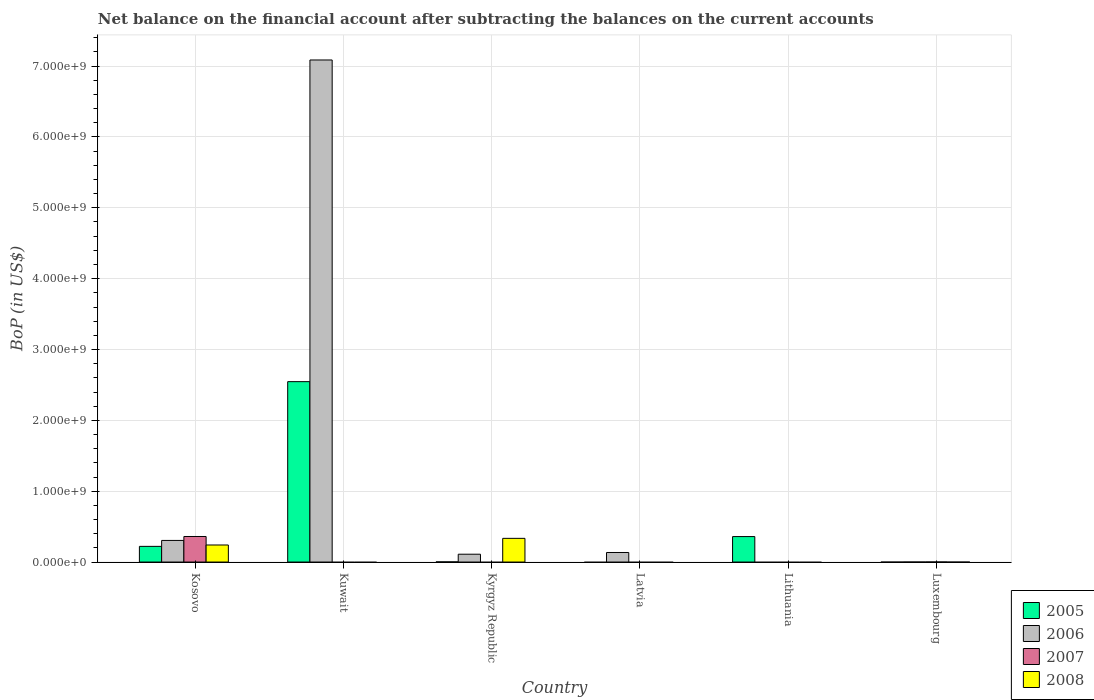What is the label of the 5th group of bars from the left?
Provide a short and direct response. Lithuania. In how many cases, is the number of bars for a given country not equal to the number of legend labels?
Make the answer very short. 5. What is the Balance of Payments in 2006 in Kuwait?
Offer a terse response. 7.09e+09. Across all countries, what is the maximum Balance of Payments in 2006?
Give a very brief answer. 7.09e+09. In which country was the Balance of Payments in 2008 maximum?
Ensure brevity in your answer.  Kyrgyz Republic. What is the total Balance of Payments in 2008 in the graph?
Your answer should be very brief. 5.75e+08. What is the difference between the Balance of Payments in 2005 in Kuwait and that in Lithuania?
Your response must be concise. 2.19e+09. What is the difference between the Balance of Payments in 2007 in Kyrgyz Republic and the Balance of Payments in 2006 in Lithuania?
Provide a succinct answer. 0. What is the average Balance of Payments in 2008 per country?
Your answer should be very brief. 9.58e+07. What is the difference between the Balance of Payments of/in 2008 and Balance of Payments of/in 2006 in Kyrgyz Republic?
Your answer should be very brief. 2.24e+08. In how many countries, is the Balance of Payments in 2005 greater than 3600000000 US$?
Make the answer very short. 0. What is the ratio of the Balance of Payments in 2005 in Kosovo to that in Kuwait?
Provide a succinct answer. 0.09. Is the Balance of Payments in 2005 in Kosovo less than that in Lithuania?
Ensure brevity in your answer.  Yes. What is the difference between the highest and the second highest Balance of Payments in 2006?
Make the answer very short. -6.78e+09. What is the difference between the highest and the lowest Balance of Payments in 2007?
Ensure brevity in your answer.  3.60e+08. In how many countries, is the Balance of Payments in 2006 greater than the average Balance of Payments in 2006 taken over all countries?
Your answer should be very brief. 1. Is it the case that in every country, the sum of the Balance of Payments in 2007 and Balance of Payments in 2008 is greater than the Balance of Payments in 2005?
Your answer should be very brief. No. Are all the bars in the graph horizontal?
Give a very brief answer. No. Are the values on the major ticks of Y-axis written in scientific E-notation?
Provide a succinct answer. Yes. Does the graph contain any zero values?
Keep it short and to the point. Yes. Where does the legend appear in the graph?
Ensure brevity in your answer.  Bottom right. How many legend labels are there?
Offer a very short reply. 4. What is the title of the graph?
Your response must be concise. Net balance on the financial account after subtracting the balances on the current accounts. What is the label or title of the Y-axis?
Ensure brevity in your answer.  BoP (in US$). What is the BoP (in US$) of 2005 in Kosovo?
Keep it short and to the point. 2.21e+08. What is the BoP (in US$) of 2006 in Kosovo?
Offer a terse response. 3.05e+08. What is the BoP (in US$) in 2007 in Kosovo?
Offer a very short reply. 3.60e+08. What is the BoP (in US$) of 2008 in Kosovo?
Offer a very short reply. 2.41e+08. What is the BoP (in US$) of 2005 in Kuwait?
Offer a terse response. 2.55e+09. What is the BoP (in US$) of 2006 in Kuwait?
Make the answer very short. 7.09e+09. What is the BoP (in US$) in 2007 in Kuwait?
Make the answer very short. 0. What is the BoP (in US$) in 2008 in Kuwait?
Make the answer very short. 0. What is the BoP (in US$) in 2005 in Kyrgyz Republic?
Offer a very short reply. 2.12e+06. What is the BoP (in US$) in 2006 in Kyrgyz Republic?
Give a very brief answer. 1.10e+08. What is the BoP (in US$) of 2007 in Kyrgyz Republic?
Give a very brief answer. 0. What is the BoP (in US$) of 2008 in Kyrgyz Republic?
Offer a terse response. 3.34e+08. What is the BoP (in US$) of 2005 in Latvia?
Your response must be concise. 0. What is the BoP (in US$) in 2006 in Latvia?
Your answer should be compact. 1.35e+08. What is the BoP (in US$) of 2008 in Latvia?
Your answer should be very brief. 0. What is the BoP (in US$) in 2005 in Lithuania?
Your response must be concise. 3.60e+08. What is the BoP (in US$) in 2006 in Luxembourg?
Ensure brevity in your answer.  0. What is the BoP (in US$) of 2007 in Luxembourg?
Your answer should be compact. 4.90e+05. What is the BoP (in US$) in 2008 in Luxembourg?
Offer a very short reply. 0. Across all countries, what is the maximum BoP (in US$) of 2005?
Give a very brief answer. 2.55e+09. Across all countries, what is the maximum BoP (in US$) of 2006?
Provide a succinct answer. 7.09e+09. Across all countries, what is the maximum BoP (in US$) in 2007?
Your answer should be very brief. 3.60e+08. Across all countries, what is the maximum BoP (in US$) in 2008?
Your answer should be compact. 3.34e+08. Across all countries, what is the minimum BoP (in US$) in 2005?
Give a very brief answer. 0. Across all countries, what is the minimum BoP (in US$) of 2007?
Your answer should be very brief. 0. What is the total BoP (in US$) in 2005 in the graph?
Offer a terse response. 3.13e+09. What is the total BoP (in US$) of 2006 in the graph?
Provide a short and direct response. 7.64e+09. What is the total BoP (in US$) of 2007 in the graph?
Your answer should be very brief. 3.61e+08. What is the total BoP (in US$) in 2008 in the graph?
Ensure brevity in your answer.  5.75e+08. What is the difference between the BoP (in US$) in 2005 in Kosovo and that in Kuwait?
Your response must be concise. -2.33e+09. What is the difference between the BoP (in US$) of 2006 in Kosovo and that in Kuwait?
Offer a very short reply. -6.78e+09. What is the difference between the BoP (in US$) of 2005 in Kosovo and that in Kyrgyz Republic?
Provide a succinct answer. 2.19e+08. What is the difference between the BoP (in US$) of 2006 in Kosovo and that in Kyrgyz Republic?
Your response must be concise. 1.95e+08. What is the difference between the BoP (in US$) of 2008 in Kosovo and that in Kyrgyz Republic?
Provide a succinct answer. -9.37e+07. What is the difference between the BoP (in US$) of 2006 in Kosovo and that in Latvia?
Keep it short and to the point. 1.70e+08. What is the difference between the BoP (in US$) in 2005 in Kosovo and that in Lithuania?
Offer a terse response. -1.38e+08. What is the difference between the BoP (in US$) in 2007 in Kosovo and that in Luxembourg?
Give a very brief answer. 3.60e+08. What is the difference between the BoP (in US$) of 2005 in Kuwait and that in Kyrgyz Republic?
Your response must be concise. 2.54e+09. What is the difference between the BoP (in US$) of 2006 in Kuwait and that in Kyrgyz Republic?
Provide a short and direct response. 6.98e+09. What is the difference between the BoP (in US$) in 2006 in Kuwait and that in Latvia?
Give a very brief answer. 6.95e+09. What is the difference between the BoP (in US$) of 2005 in Kuwait and that in Lithuania?
Make the answer very short. 2.19e+09. What is the difference between the BoP (in US$) of 2006 in Kyrgyz Republic and that in Latvia?
Give a very brief answer. -2.42e+07. What is the difference between the BoP (in US$) of 2005 in Kyrgyz Republic and that in Lithuania?
Your response must be concise. -3.57e+08. What is the difference between the BoP (in US$) in 2005 in Kosovo and the BoP (in US$) in 2006 in Kuwait?
Your response must be concise. -6.87e+09. What is the difference between the BoP (in US$) of 2005 in Kosovo and the BoP (in US$) of 2006 in Kyrgyz Republic?
Your answer should be very brief. 1.11e+08. What is the difference between the BoP (in US$) in 2005 in Kosovo and the BoP (in US$) in 2008 in Kyrgyz Republic?
Your answer should be compact. -1.13e+08. What is the difference between the BoP (in US$) in 2006 in Kosovo and the BoP (in US$) in 2008 in Kyrgyz Republic?
Ensure brevity in your answer.  -2.94e+07. What is the difference between the BoP (in US$) of 2007 in Kosovo and the BoP (in US$) of 2008 in Kyrgyz Republic?
Provide a short and direct response. 2.61e+07. What is the difference between the BoP (in US$) of 2005 in Kosovo and the BoP (in US$) of 2006 in Latvia?
Give a very brief answer. 8.66e+07. What is the difference between the BoP (in US$) of 2005 in Kosovo and the BoP (in US$) of 2007 in Luxembourg?
Provide a succinct answer. 2.21e+08. What is the difference between the BoP (in US$) in 2006 in Kosovo and the BoP (in US$) in 2007 in Luxembourg?
Make the answer very short. 3.04e+08. What is the difference between the BoP (in US$) of 2005 in Kuwait and the BoP (in US$) of 2006 in Kyrgyz Republic?
Keep it short and to the point. 2.44e+09. What is the difference between the BoP (in US$) in 2005 in Kuwait and the BoP (in US$) in 2008 in Kyrgyz Republic?
Ensure brevity in your answer.  2.21e+09. What is the difference between the BoP (in US$) of 2006 in Kuwait and the BoP (in US$) of 2008 in Kyrgyz Republic?
Provide a short and direct response. 6.75e+09. What is the difference between the BoP (in US$) of 2005 in Kuwait and the BoP (in US$) of 2006 in Latvia?
Ensure brevity in your answer.  2.41e+09. What is the difference between the BoP (in US$) of 2005 in Kuwait and the BoP (in US$) of 2007 in Luxembourg?
Offer a very short reply. 2.55e+09. What is the difference between the BoP (in US$) of 2006 in Kuwait and the BoP (in US$) of 2007 in Luxembourg?
Offer a very short reply. 7.09e+09. What is the difference between the BoP (in US$) in 2005 in Kyrgyz Republic and the BoP (in US$) in 2006 in Latvia?
Your response must be concise. -1.32e+08. What is the difference between the BoP (in US$) in 2005 in Kyrgyz Republic and the BoP (in US$) in 2007 in Luxembourg?
Make the answer very short. 1.63e+06. What is the difference between the BoP (in US$) in 2006 in Kyrgyz Republic and the BoP (in US$) in 2007 in Luxembourg?
Your response must be concise. 1.10e+08. What is the difference between the BoP (in US$) in 2006 in Latvia and the BoP (in US$) in 2007 in Luxembourg?
Keep it short and to the point. 1.34e+08. What is the difference between the BoP (in US$) in 2005 in Lithuania and the BoP (in US$) in 2007 in Luxembourg?
Your answer should be very brief. 3.59e+08. What is the average BoP (in US$) of 2005 per country?
Make the answer very short. 5.22e+08. What is the average BoP (in US$) of 2006 per country?
Make the answer very short. 1.27e+09. What is the average BoP (in US$) of 2007 per country?
Provide a succinct answer. 6.02e+07. What is the average BoP (in US$) in 2008 per country?
Keep it short and to the point. 9.58e+07. What is the difference between the BoP (in US$) in 2005 and BoP (in US$) in 2006 in Kosovo?
Make the answer very short. -8.37e+07. What is the difference between the BoP (in US$) of 2005 and BoP (in US$) of 2007 in Kosovo?
Your answer should be compact. -1.39e+08. What is the difference between the BoP (in US$) in 2005 and BoP (in US$) in 2008 in Kosovo?
Offer a very short reply. -1.93e+07. What is the difference between the BoP (in US$) in 2006 and BoP (in US$) in 2007 in Kosovo?
Make the answer very short. -5.55e+07. What is the difference between the BoP (in US$) in 2006 and BoP (in US$) in 2008 in Kosovo?
Provide a succinct answer. 6.44e+07. What is the difference between the BoP (in US$) of 2007 and BoP (in US$) of 2008 in Kosovo?
Your answer should be compact. 1.20e+08. What is the difference between the BoP (in US$) in 2005 and BoP (in US$) in 2006 in Kuwait?
Ensure brevity in your answer.  -4.54e+09. What is the difference between the BoP (in US$) of 2005 and BoP (in US$) of 2006 in Kyrgyz Republic?
Make the answer very short. -1.08e+08. What is the difference between the BoP (in US$) of 2005 and BoP (in US$) of 2008 in Kyrgyz Republic?
Your answer should be compact. -3.32e+08. What is the difference between the BoP (in US$) of 2006 and BoP (in US$) of 2008 in Kyrgyz Republic?
Give a very brief answer. -2.24e+08. What is the ratio of the BoP (in US$) in 2005 in Kosovo to that in Kuwait?
Offer a terse response. 0.09. What is the ratio of the BoP (in US$) of 2006 in Kosovo to that in Kuwait?
Provide a short and direct response. 0.04. What is the ratio of the BoP (in US$) in 2005 in Kosovo to that in Kyrgyz Republic?
Ensure brevity in your answer.  104.42. What is the ratio of the BoP (in US$) of 2006 in Kosovo to that in Kyrgyz Republic?
Keep it short and to the point. 2.76. What is the ratio of the BoP (in US$) of 2008 in Kosovo to that in Kyrgyz Republic?
Provide a short and direct response. 0.72. What is the ratio of the BoP (in US$) in 2006 in Kosovo to that in Latvia?
Provide a succinct answer. 2.27. What is the ratio of the BoP (in US$) in 2005 in Kosovo to that in Lithuania?
Your response must be concise. 0.62. What is the ratio of the BoP (in US$) in 2007 in Kosovo to that in Luxembourg?
Offer a terse response. 734.91. What is the ratio of the BoP (in US$) of 2005 in Kuwait to that in Kyrgyz Republic?
Ensure brevity in your answer.  1201.81. What is the ratio of the BoP (in US$) of 2006 in Kuwait to that in Kyrgyz Republic?
Offer a terse response. 64.19. What is the ratio of the BoP (in US$) in 2006 in Kuwait to that in Latvia?
Give a very brief answer. 52.65. What is the ratio of the BoP (in US$) in 2005 in Kuwait to that in Lithuania?
Provide a succinct answer. 7.08. What is the ratio of the BoP (in US$) of 2006 in Kyrgyz Republic to that in Latvia?
Ensure brevity in your answer.  0.82. What is the ratio of the BoP (in US$) in 2005 in Kyrgyz Republic to that in Lithuania?
Your answer should be very brief. 0.01. What is the difference between the highest and the second highest BoP (in US$) in 2005?
Your answer should be very brief. 2.19e+09. What is the difference between the highest and the second highest BoP (in US$) of 2006?
Ensure brevity in your answer.  6.78e+09. What is the difference between the highest and the lowest BoP (in US$) of 2005?
Your response must be concise. 2.55e+09. What is the difference between the highest and the lowest BoP (in US$) of 2006?
Your answer should be compact. 7.09e+09. What is the difference between the highest and the lowest BoP (in US$) of 2007?
Your answer should be compact. 3.60e+08. What is the difference between the highest and the lowest BoP (in US$) in 2008?
Keep it short and to the point. 3.34e+08. 